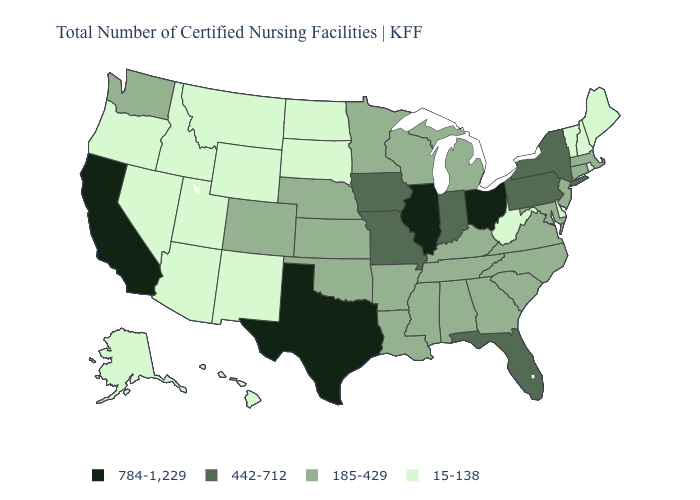Among the states that border Delaware , does Pennsylvania have the highest value?
Answer briefly. Yes. How many symbols are there in the legend?
Answer briefly. 4. Which states have the lowest value in the USA?
Give a very brief answer. Alaska, Arizona, Delaware, Hawaii, Idaho, Maine, Montana, Nevada, New Hampshire, New Mexico, North Dakota, Oregon, Rhode Island, South Dakota, Utah, Vermont, West Virginia, Wyoming. Name the states that have a value in the range 185-429?
Give a very brief answer. Alabama, Arkansas, Colorado, Connecticut, Georgia, Kansas, Kentucky, Louisiana, Maryland, Massachusetts, Michigan, Minnesota, Mississippi, Nebraska, New Jersey, North Carolina, Oklahoma, South Carolina, Tennessee, Virginia, Washington, Wisconsin. Which states have the highest value in the USA?
Answer briefly. California, Illinois, Ohio, Texas. What is the lowest value in states that border Wyoming?
Concise answer only. 15-138. Name the states that have a value in the range 784-1,229?
Quick response, please. California, Illinois, Ohio, Texas. What is the highest value in states that border Vermont?
Short answer required. 442-712. Which states have the lowest value in the South?
Give a very brief answer. Delaware, West Virginia. What is the value of Texas?
Quick response, please. 784-1,229. Among the states that border Vermont , which have the highest value?
Write a very short answer. New York. What is the lowest value in the USA?
Give a very brief answer. 15-138. Name the states that have a value in the range 185-429?
Answer briefly. Alabama, Arkansas, Colorado, Connecticut, Georgia, Kansas, Kentucky, Louisiana, Maryland, Massachusetts, Michigan, Minnesota, Mississippi, Nebraska, New Jersey, North Carolina, Oklahoma, South Carolina, Tennessee, Virginia, Washington, Wisconsin. What is the value of Wyoming?
Concise answer only. 15-138. Name the states that have a value in the range 15-138?
Give a very brief answer. Alaska, Arizona, Delaware, Hawaii, Idaho, Maine, Montana, Nevada, New Hampshire, New Mexico, North Dakota, Oregon, Rhode Island, South Dakota, Utah, Vermont, West Virginia, Wyoming. 